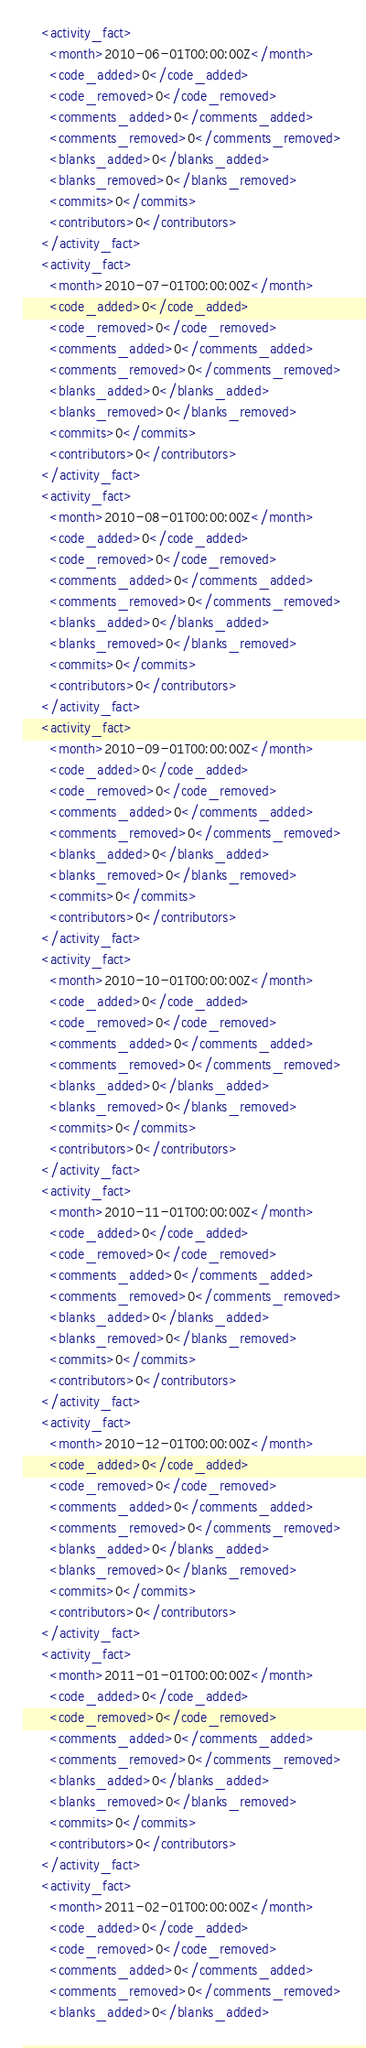Convert code to text. <code><loc_0><loc_0><loc_500><loc_500><_XML_>    <activity_fact>
      <month>2010-06-01T00:00:00Z</month>
      <code_added>0</code_added>
      <code_removed>0</code_removed>
      <comments_added>0</comments_added>
      <comments_removed>0</comments_removed>
      <blanks_added>0</blanks_added>
      <blanks_removed>0</blanks_removed>
      <commits>0</commits>
      <contributors>0</contributors>
    </activity_fact>
    <activity_fact>
      <month>2010-07-01T00:00:00Z</month>
      <code_added>0</code_added>
      <code_removed>0</code_removed>
      <comments_added>0</comments_added>
      <comments_removed>0</comments_removed>
      <blanks_added>0</blanks_added>
      <blanks_removed>0</blanks_removed>
      <commits>0</commits>
      <contributors>0</contributors>
    </activity_fact>
    <activity_fact>
      <month>2010-08-01T00:00:00Z</month>
      <code_added>0</code_added>
      <code_removed>0</code_removed>
      <comments_added>0</comments_added>
      <comments_removed>0</comments_removed>
      <blanks_added>0</blanks_added>
      <blanks_removed>0</blanks_removed>
      <commits>0</commits>
      <contributors>0</contributors>
    </activity_fact>
    <activity_fact>
      <month>2010-09-01T00:00:00Z</month>
      <code_added>0</code_added>
      <code_removed>0</code_removed>
      <comments_added>0</comments_added>
      <comments_removed>0</comments_removed>
      <blanks_added>0</blanks_added>
      <blanks_removed>0</blanks_removed>
      <commits>0</commits>
      <contributors>0</contributors>
    </activity_fact>
    <activity_fact>
      <month>2010-10-01T00:00:00Z</month>
      <code_added>0</code_added>
      <code_removed>0</code_removed>
      <comments_added>0</comments_added>
      <comments_removed>0</comments_removed>
      <blanks_added>0</blanks_added>
      <blanks_removed>0</blanks_removed>
      <commits>0</commits>
      <contributors>0</contributors>
    </activity_fact>
    <activity_fact>
      <month>2010-11-01T00:00:00Z</month>
      <code_added>0</code_added>
      <code_removed>0</code_removed>
      <comments_added>0</comments_added>
      <comments_removed>0</comments_removed>
      <blanks_added>0</blanks_added>
      <blanks_removed>0</blanks_removed>
      <commits>0</commits>
      <contributors>0</contributors>
    </activity_fact>
    <activity_fact>
      <month>2010-12-01T00:00:00Z</month>
      <code_added>0</code_added>
      <code_removed>0</code_removed>
      <comments_added>0</comments_added>
      <comments_removed>0</comments_removed>
      <blanks_added>0</blanks_added>
      <blanks_removed>0</blanks_removed>
      <commits>0</commits>
      <contributors>0</contributors>
    </activity_fact>
    <activity_fact>
      <month>2011-01-01T00:00:00Z</month>
      <code_added>0</code_added>
      <code_removed>0</code_removed>
      <comments_added>0</comments_added>
      <comments_removed>0</comments_removed>
      <blanks_added>0</blanks_added>
      <blanks_removed>0</blanks_removed>
      <commits>0</commits>
      <contributors>0</contributors>
    </activity_fact>
    <activity_fact>
      <month>2011-02-01T00:00:00Z</month>
      <code_added>0</code_added>
      <code_removed>0</code_removed>
      <comments_added>0</comments_added>
      <comments_removed>0</comments_removed>
      <blanks_added>0</blanks_added></code> 